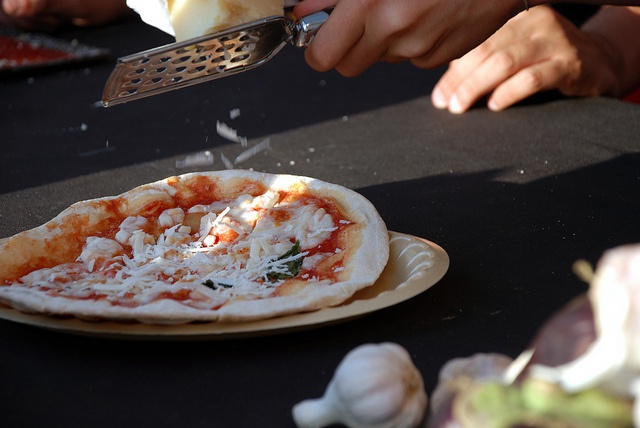Describe the objects in this image and their specific colors. I can see dining table in black, darkgray, gray, and maroon tones, pizza in black, darkgray, gray, maroon, and brown tones, people in black, maroon, and tan tones, and people in black, maroon, and brown tones in this image. 